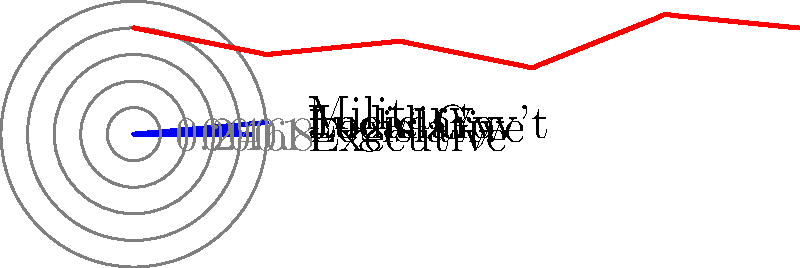Based on the radar chart showing corruption levels across different branches of government, which branch appears to have the highest perceived level of corruption, and how does this compare to the branch with the lowest perceived corruption? To answer this question, we need to analyze the radar chart:

1. Identify the branches represented: Executive, Legislative, Judiciary, Local Government, and Military.

2. Examine the scale: The chart uses a scale from 0 to 1, where higher values indicate higher levels of perceived corruption.

3. Identify the highest point:
   - The Military branch extends furthest from the center, reaching close to 0.9 on the scale.

4. Identify the lowest point:
   - The Local Government branch is closest to the center, at approximately 0.5 on the scale.

5. Compare the highest and lowest:
   - The Military (highest) is at about 0.9
   - Local Government (lowest) is at about 0.5
   - The difference is approximately 0.4 or 40 percentage points

6. Interpret the results:
   - The Military is perceived as the most corrupt branch
   - Local Government is perceived as the least corrupt branch
   - The Military's corruption level is nearly twice that of Local Government
Answer: The Military has the highest perceived corruption (0.9), which is 0.4 (or 40 percentage points) higher than Local Government, the lowest at 0.5. 